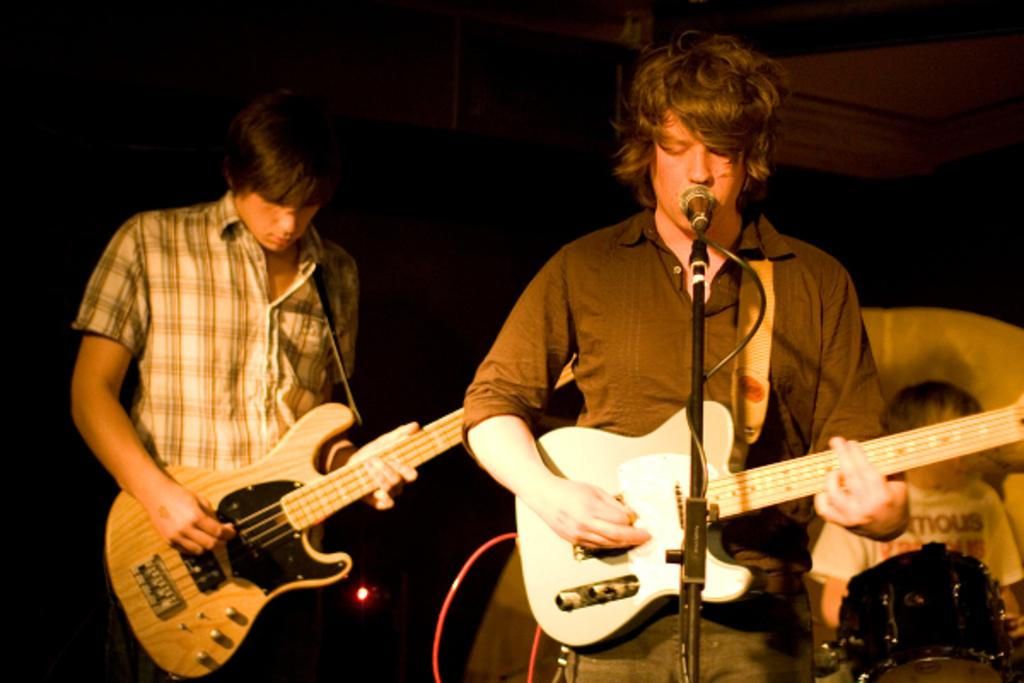How many people are in the image? There are three men in the image. What are two of the men doing? Two of the men are playing guitars. What is the third man doing? The third man is playing drums. What is in front of the man playing drums? There is a microphone in front of the man playing drums. What might the man with the microphone be doing? The man with the microphone appears to be singing. What is the color of the background in the image? The background of the image is dark. What is the price of the alarm clock on the table in the image? There is no alarm clock present in the image. What type of straw is being used by the man playing drums? There is no straw present in the image. 